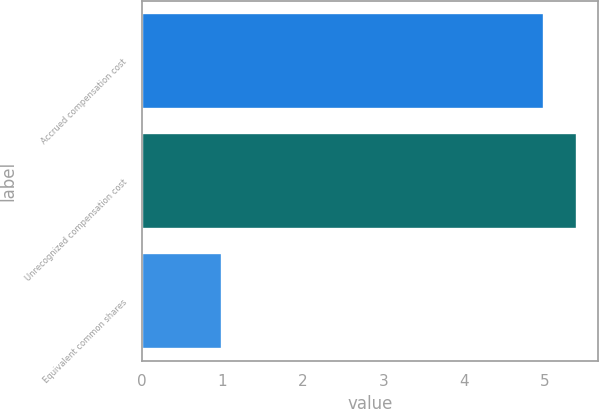<chart> <loc_0><loc_0><loc_500><loc_500><bar_chart><fcel>Accrued compensation cost<fcel>Unrecognized compensation cost<fcel>Equivalent common shares<nl><fcel>5<fcel>5.4<fcel>1<nl></chart> 